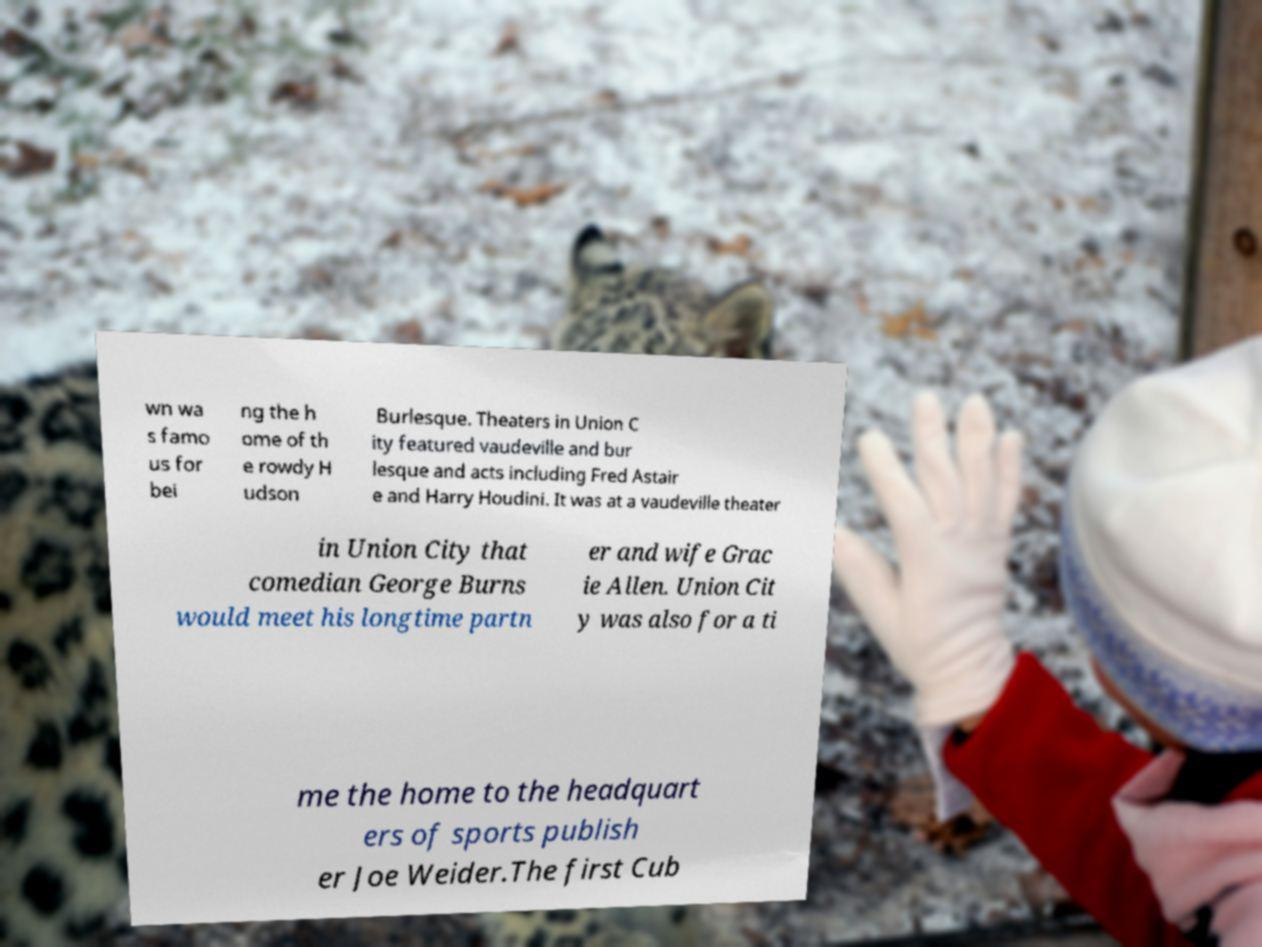For documentation purposes, I need the text within this image transcribed. Could you provide that? wn wa s famo us for bei ng the h ome of th e rowdy H udson Burlesque. Theaters in Union C ity featured vaudeville and bur lesque and acts including Fred Astair e and Harry Houdini. It was at a vaudeville theater in Union City that comedian George Burns would meet his longtime partn er and wife Grac ie Allen. Union Cit y was also for a ti me the home to the headquart ers of sports publish er Joe Weider.The first Cub 